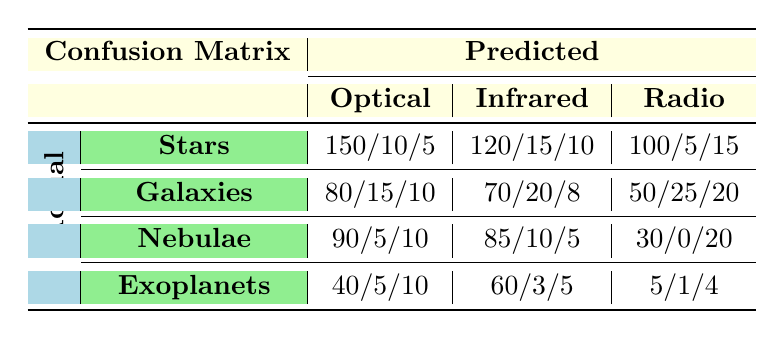What is the True Positive value for Nebulae detected using Optical imaging? The True Positive value for Nebulae using Optical imaging is listed in the table under the Nebulae row and Optical column, where it shows 90.
Answer: 90 What is the False Positive rate for Radio imaging when detecting Exoplanets? The False Positive value for Exoplanets using Radio imaging is found in the Exoplanets row and Radio column, which indicates 1.
Answer: 1 What is the total number of False Negatives across all types for Infrared imaging? We find the False Negative values for Infrared imaging by summing all the False Negative figures from each object type: (10 + 8 + 5 + 5) = 28.
Answer: 28 True or False: The number of True Positives for Stars is greater than the True Positives for Galaxies in Optical imaging. For Stars, the True Positive count in Optical imaging is 150, while for Galaxies it is 80, meaning the statement is True.
Answer: True What is the best imaging technique for detecting Galaxies based on True Positive values? By comparing the True Positive values across different imaging techniques for Galaxies, we see the values are 80 (Optical), 70 (Infrared), and 50 (Radio). Thus, the Optical technique has the highest value.
Answer: Optical How many more False Negatives are there for Nebulae in Optical compared to Radio imaging? The False Negative for Nebulae in Optical is 10, and for Radio it is 20. The difference is 10 - 20 = -10, indicating there are 10 more for Radio imaging.
Answer: 10 more for Radio What is the average True Positive value across all types for Infrared imaging? The True Positive values for Infrared imaging are 120 (Stars), 70 (Galaxies), 85 (Nebulae), and 60 (Exoplanets). To find the average, we sum these values: 120 + 70 + 85 + 60 = 335, then divide by 4 (the number of object types): 335 / 4 = 83.75.
Answer: 83.75 True or False: The False Positive count for Radio imaging in Nebulae is equal to the False Negative count in Stars for Radio imaging. The False Positive count for Radio in Nebulae is 0, and the False Negative count for Stars in Radio is 15. Since 0 does not equal 15, the statement is False.
Answer: False Which object type has the highest False Positive counts in Radio imaging? The False Positive values for Radio imaging are: Stars (5), Galaxies (25), Nebulae (0), Exoplanets (1). Galaxies have the highest False Positive count at 25.
Answer: Galaxies 